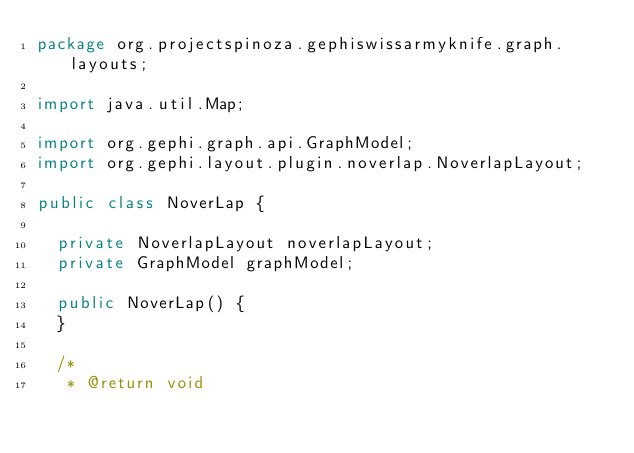<code> <loc_0><loc_0><loc_500><loc_500><_Java_>package org.projectspinoza.gephiswissarmyknife.graph.layouts;

import java.util.Map;

import org.gephi.graph.api.GraphModel;
import org.gephi.layout.plugin.noverlap.NoverlapLayout;

public class NoverLap {

  private NoverlapLayout noverlapLayout;
  private GraphModel graphModel;

  public NoverLap() {
  }
  
  /*
   * @return void</code> 